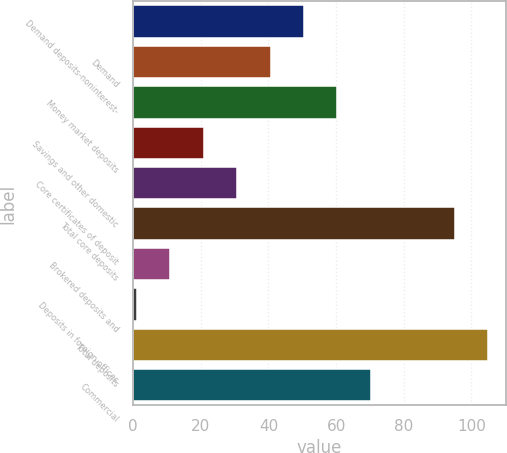<chart> <loc_0><loc_0><loc_500><loc_500><bar_chart><fcel>Demand deposits-noninterest-<fcel>Demand<fcel>Money market deposits<fcel>Savings and other domestic<fcel>Core certificates of deposit<fcel>Total core deposits<fcel>Brokered deposits and<fcel>Deposits in foreign offices<fcel>Total deposits<fcel>Commercial<nl><fcel>50.5<fcel>40.6<fcel>60.4<fcel>20.8<fcel>30.7<fcel>95<fcel>10.9<fcel>1<fcel>104.9<fcel>70.3<nl></chart> 